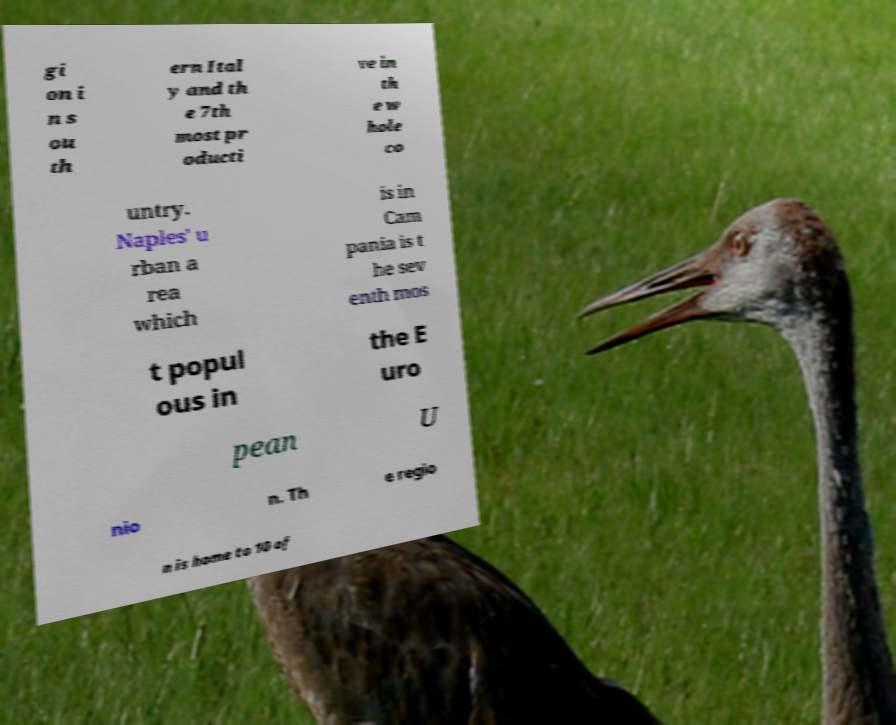Please read and relay the text visible in this image. What does it say? gi on i n s ou th ern Ital y and th e 7th most pr oducti ve in th e w hole co untry. Naples' u rban a rea which is in Cam pania is t he sev enth mos t popul ous in the E uro pean U nio n. Th e regio n is home to 10 of 